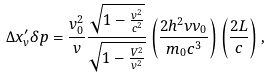Convert formula to latex. <formula><loc_0><loc_0><loc_500><loc_500>\Delta x ^ { \prime } _ { v } \delta p = \frac { v _ { 0 } ^ { 2 } } { v } \frac { \sqrt { 1 - \frac { v ^ { 2 } } { c ^ { 2 } } } } { \sqrt { 1 - \frac { V ^ { 2 } } { v ^ { 2 } } } } \left ( \frac { 2 h ^ { 2 } \nu \nu _ { 0 } } { m _ { 0 } c ^ { 3 } } \right ) \left ( \frac { 2 L } { c } \right ) ,</formula> 